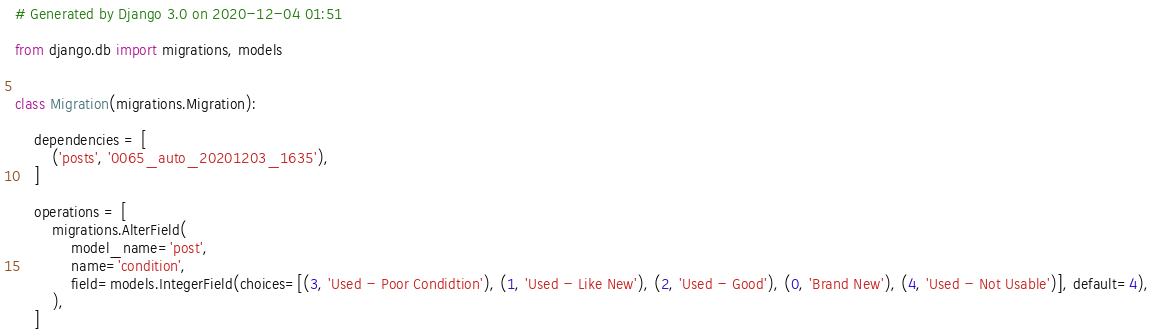Convert code to text. <code><loc_0><loc_0><loc_500><loc_500><_Python_># Generated by Django 3.0 on 2020-12-04 01:51

from django.db import migrations, models


class Migration(migrations.Migration):

    dependencies = [
        ('posts', '0065_auto_20201203_1635'),
    ]

    operations = [
        migrations.AlterField(
            model_name='post',
            name='condition',
            field=models.IntegerField(choices=[(3, 'Used - Poor Condidtion'), (1, 'Used - Like New'), (2, 'Used - Good'), (0, 'Brand New'), (4, 'Used - Not Usable')], default=4),
        ),
    ]
</code> 